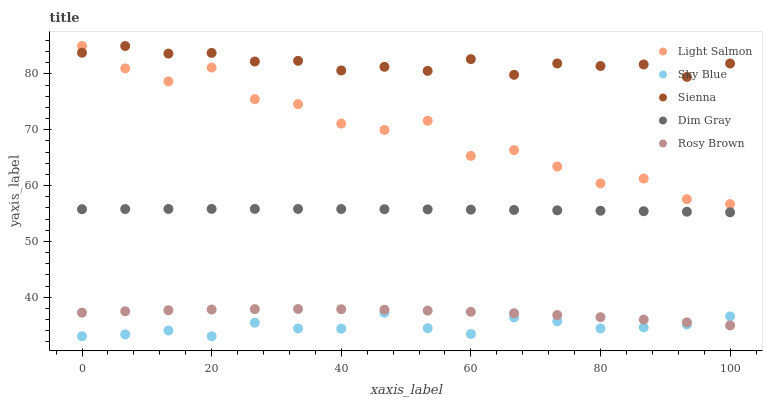Does Sky Blue have the minimum area under the curve?
Answer yes or no. Yes. Does Sienna have the maximum area under the curve?
Answer yes or no. Yes. Does Light Salmon have the minimum area under the curve?
Answer yes or no. No. Does Light Salmon have the maximum area under the curve?
Answer yes or no. No. Is Dim Gray the smoothest?
Answer yes or no. Yes. Is Light Salmon the roughest?
Answer yes or no. Yes. Is Sky Blue the smoothest?
Answer yes or no. No. Is Sky Blue the roughest?
Answer yes or no. No. Does Sky Blue have the lowest value?
Answer yes or no. Yes. Does Light Salmon have the lowest value?
Answer yes or no. No. Does Light Salmon have the highest value?
Answer yes or no. Yes. Does Sky Blue have the highest value?
Answer yes or no. No. Is Sky Blue less than Light Salmon?
Answer yes or no. Yes. Is Sienna greater than Sky Blue?
Answer yes or no. Yes. Does Sienna intersect Light Salmon?
Answer yes or no. Yes. Is Sienna less than Light Salmon?
Answer yes or no. No. Is Sienna greater than Light Salmon?
Answer yes or no. No. Does Sky Blue intersect Light Salmon?
Answer yes or no. No. 